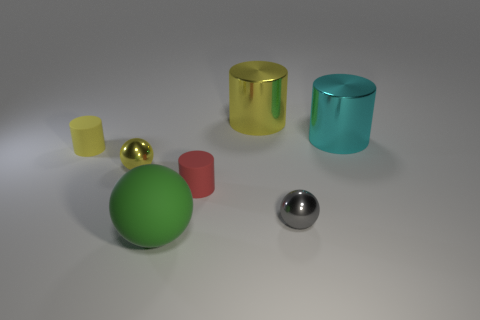Subtract all gray balls. How many yellow cylinders are left? 2 Subtract all large yellow metal cylinders. How many cylinders are left? 3 Subtract all cyan cylinders. How many cylinders are left? 3 Subtract 2 cylinders. How many cylinders are left? 2 Add 2 shiny spheres. How many objects exist? 9 Subtract all brown cylinders. Subtract all green blocks. How many cylinders are left? 4 Subtract all spheres. How many objects are left? 4 Subtract 1 gray balls. How many objects are left? 6 Subtract all yellow cylinders. Subtract all blue metal blocks. How many objects are left? 5 Add 6 metal things. How many metal things are left? 10 